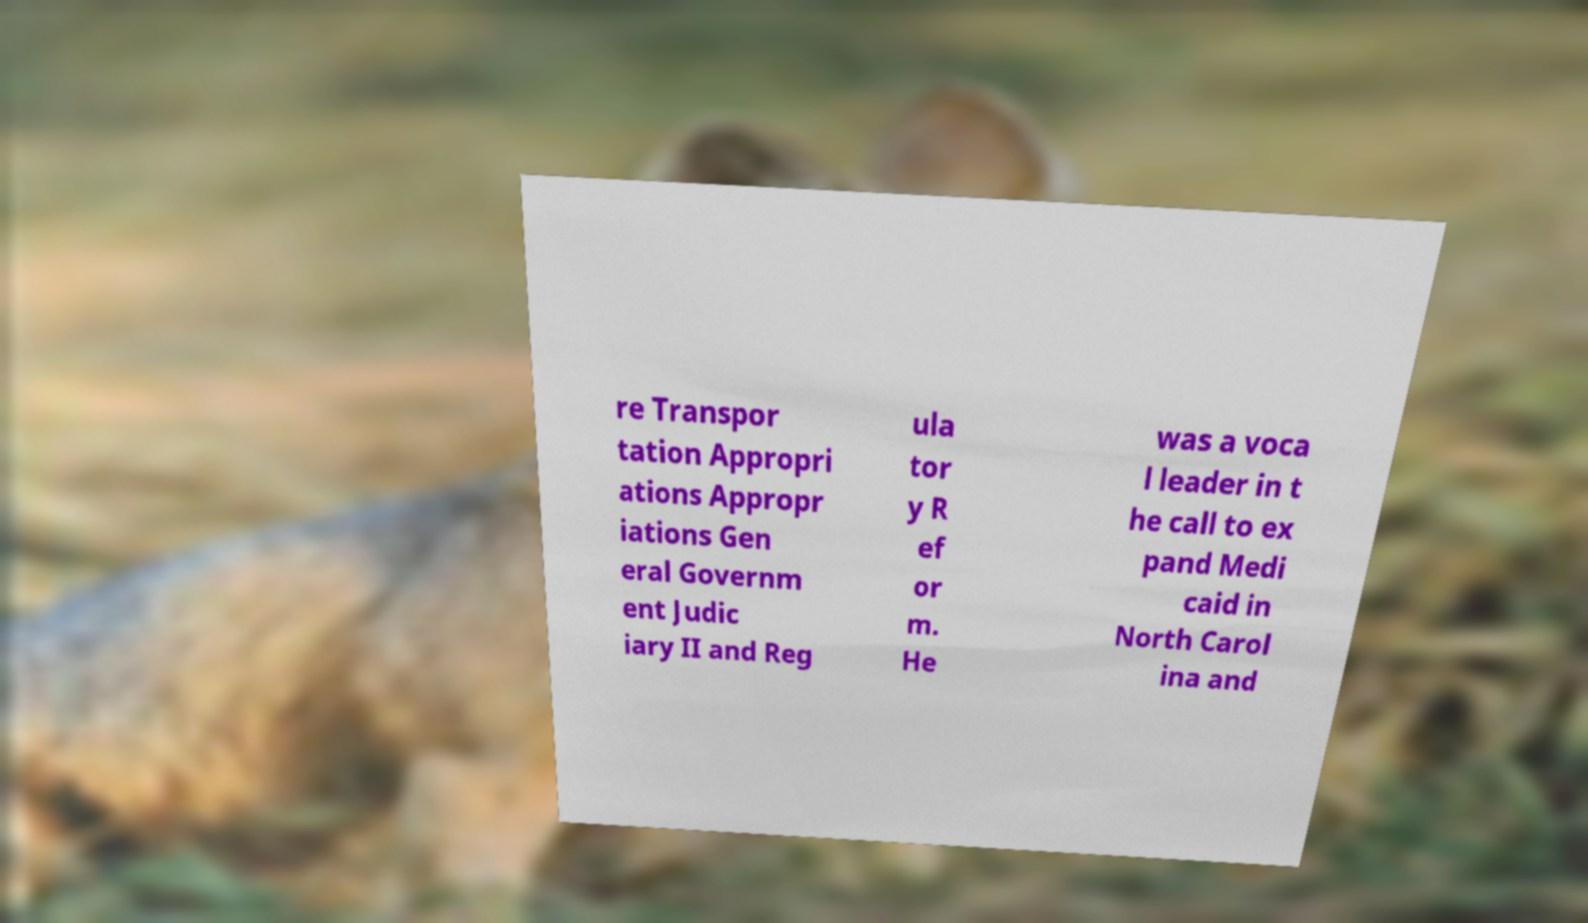For documentation purposes, I need the text within this image transcribed. Could you provide that? re Transpor tation Appropri ations Appropr iations Gen eral Governm ent Judic iary II and Reg ula tor y R ef or m. He was a voca l leader in t he call to ex pand Medi caid in North Carol ina and 